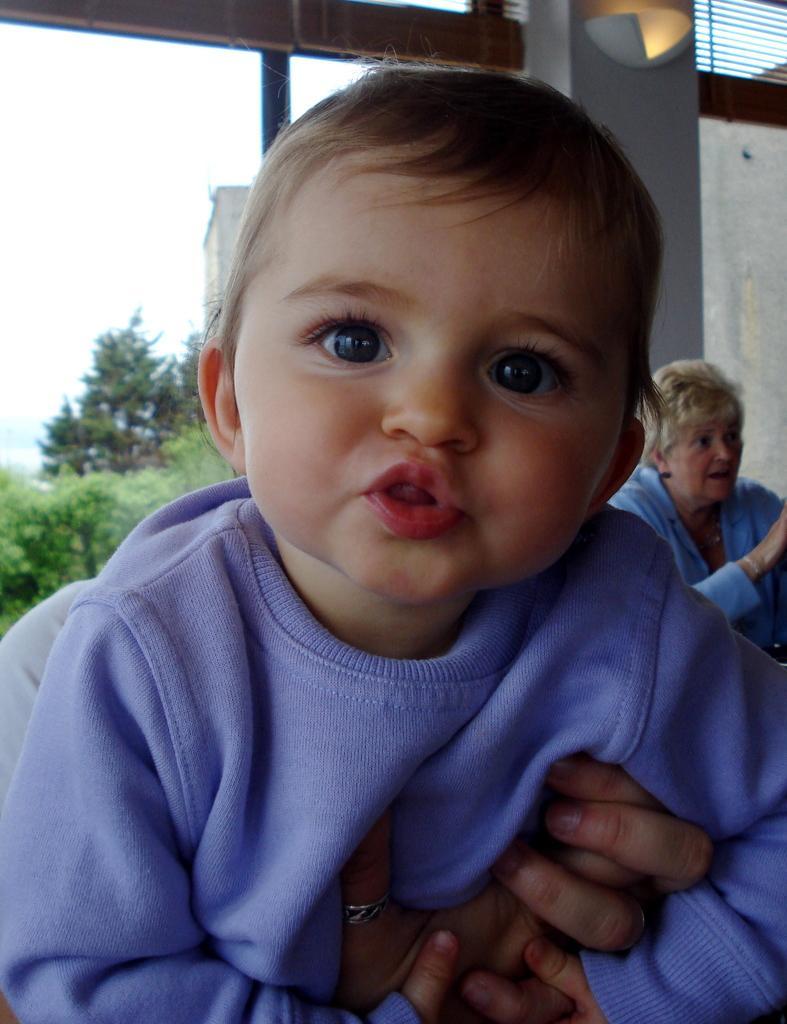Can you describe this image briefly? In this image I see a baby over here and I see that the baby is wearing purple color t-shirt and in the background I see a woman over here and I see the light over here and I see the trees and the sky. 